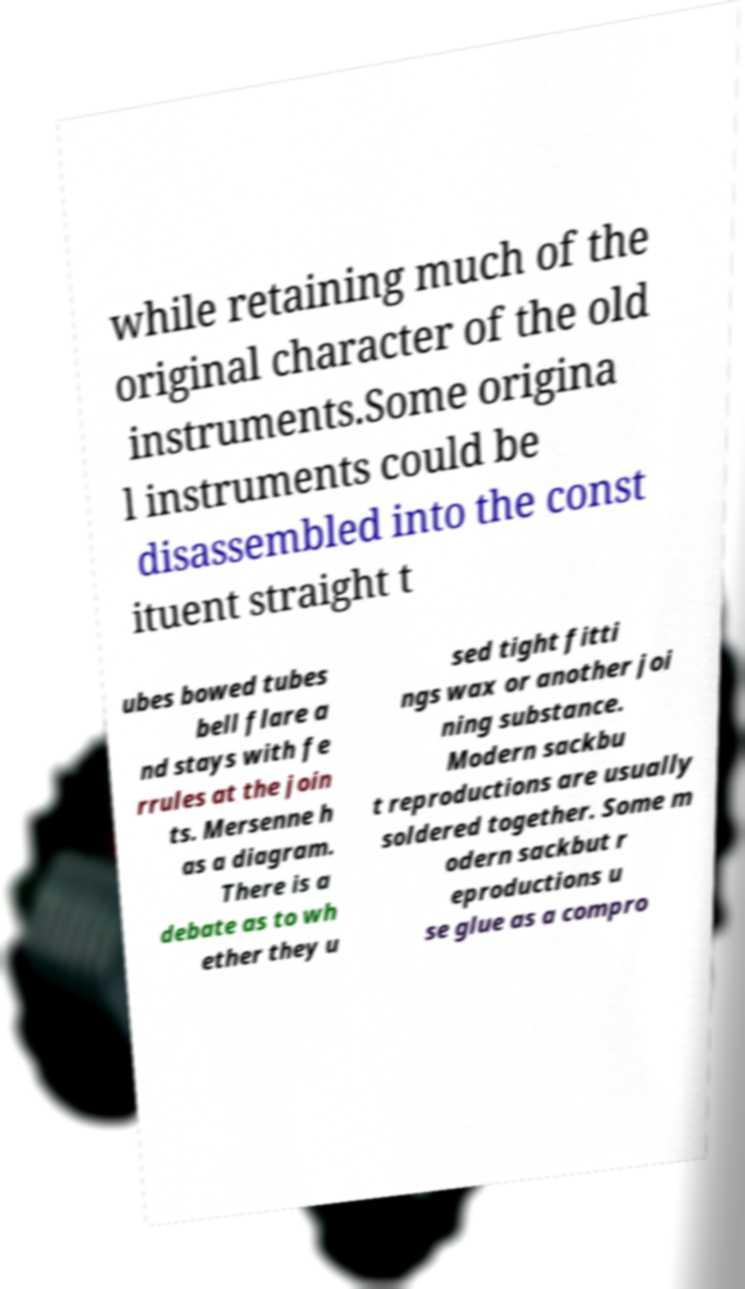Can you read and provide the text displayed in the image?This photo seems to have some interesting text. Can you extract and type it out for me? while retaining much of the original character of the old instruments.Some origina l instruments could be disassembled into the const ituent straight t ubes bowed tubes bell flare a nd stays with fe rrules at the join ts. Mersenne h as a diagram. There is a debate as to wh ether they u sed tight fitti ngs wax or another joi ning substance. Modern sackbu t reproductions are usually soldered together. Some m odern sackbut r eproductions u se glue as a compro 